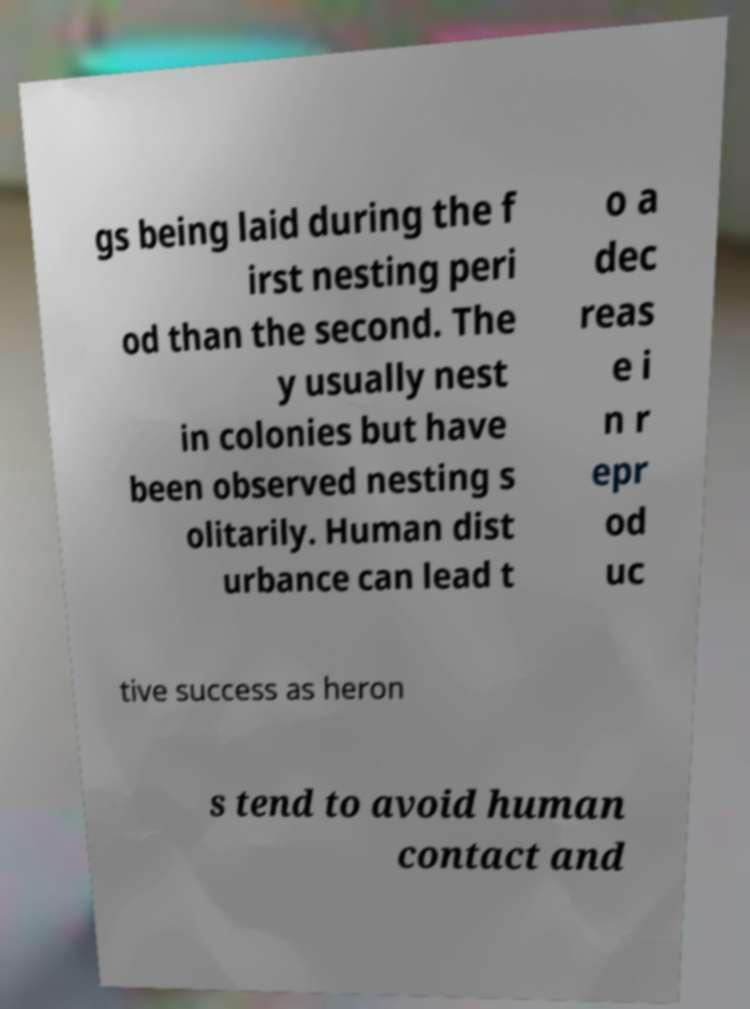There's text embedded in this image that I need extracted. Can you transcribe it verbatim? gs being laid during the f irst nesting peri od than the second. The y usually nest in colonies but have been observed nesting s olitarily. Human dist urbance can lead t o a dec reas e i n r epr od uc tive success as heron s tend to avoid human contact and 